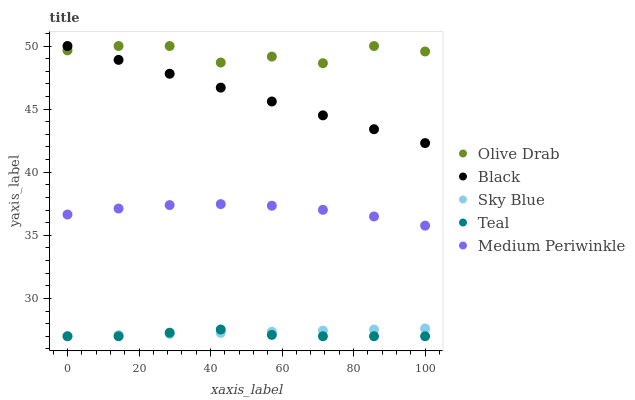Does Teal have the minimum area under the curve?
Answer yes or no. Yes. Does Olive Drab have the maximum area under the curve?
Answer yes or no. Yes. Does Black have the minimum area under the curve?
Answer yes or no. No. Does Black have the maximum area under the curve?
Answer yes or no. No. Is Black the smoothest?
Answer yes or no. Yes. Is Olive Drab the roughest?
Answer yes or no. Yes. Is Teal the smoothest?
Answer yes or no. No. Is Teal the roughest?
Answer yes or no. No. Does Sky Blue have the lowest value?
Answer yes or no. Yes. Does Black have the lowest value?
Answer yes or no. No. Does Olive Drab have the highest value?
Answer yes or no. Yes. Does Teal have the highest value?
Answer yes or no. No. Is Teal less than Black?
Answer yes or no. Yes. Is Medium Periwinkle greater than Sky Blue?
Answer yes or no. Yes. Does Black intersect Olive Drab?
Answer yes or no. Yes. Is Black less than Olive Drab?
Answer yes or no. No. Is Black greater than Olive Drab?
Answer yes or no. No. Does Teal intersect Black?
Answer yes or no. No. 